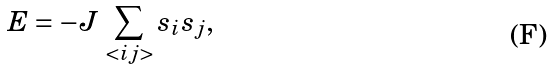Convert formula to latex. <formula><loc_0><loc_0><loc_500><loc_500>E = - J \, \sum _ { < i j > } s _ { i } s _ { j } ,</formula> 